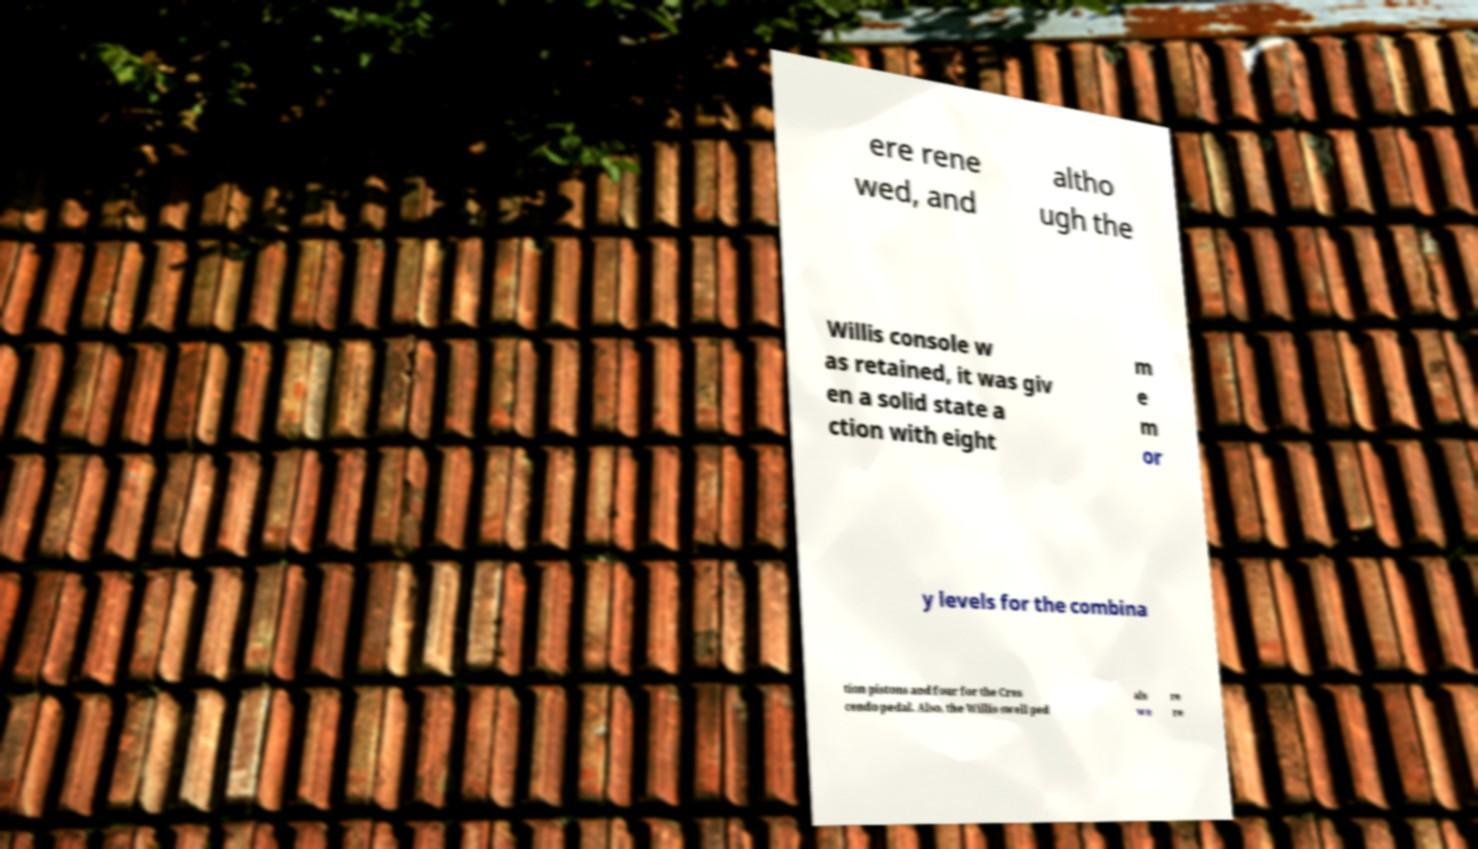Please read and relay the text visible in this image. What does it say? ere rene wed, and altho ugh the Willis console w as retained, it was giv en a solid state a ction with eight m e m or y levels for the combina tion pistons and four for the Cres cendo pedal. Also, the Willis swell ped als we re re 